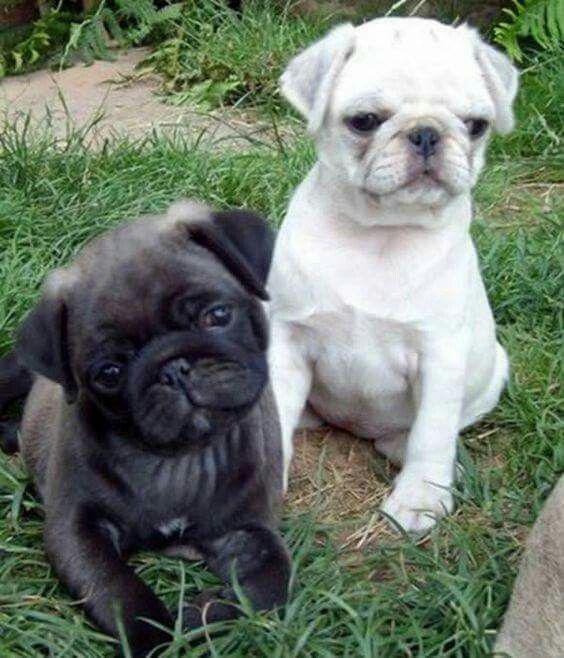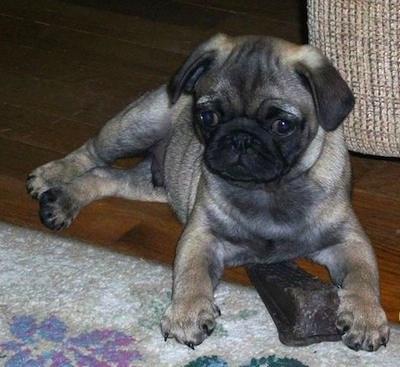The first image is the image on the left, the second image is the image on the right. For the images shown, is this caption "The right image contains exactly two dogs." true? Answer yes or no. No. The first image is the image on the left, the second image is the image on the right. Evaluate the accuracy of this statement regarding the images: "The left image features one forward-facing black pug with front paws draped over something, and the right image features a black pug to the left of a beige pug.". Is it true? Answer yes or no. No. 